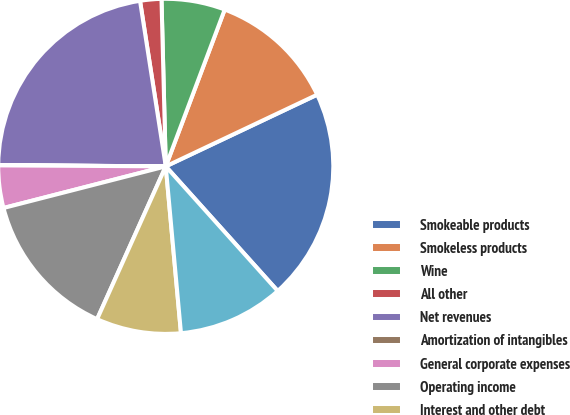Convert chart. <chart><loc_0><loc_0><loc_500><loc_500><pie_chart><fcel>Smokeable products<fcel>Smokeless products<fcel>Wine<fcel>All other<fcel>Net revenues<fcel>Amortization of intangibles<fcel>General corporate expenses<fcel>Operating income<fcel>Interest and other debt<fcel>Earnings from equity<nl><fcel>20.39%<fcel>12.24%<fcel>6.13%<fcel>2.05%<fcel>22.43%<fcel>0.02%<fcel>4.09%<fcel>14.28%<fcel>8.17%<fcel>10.2%<nl></chart> 